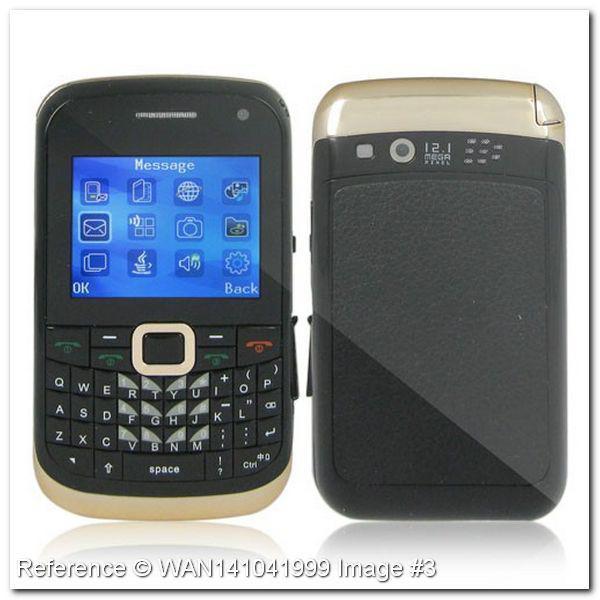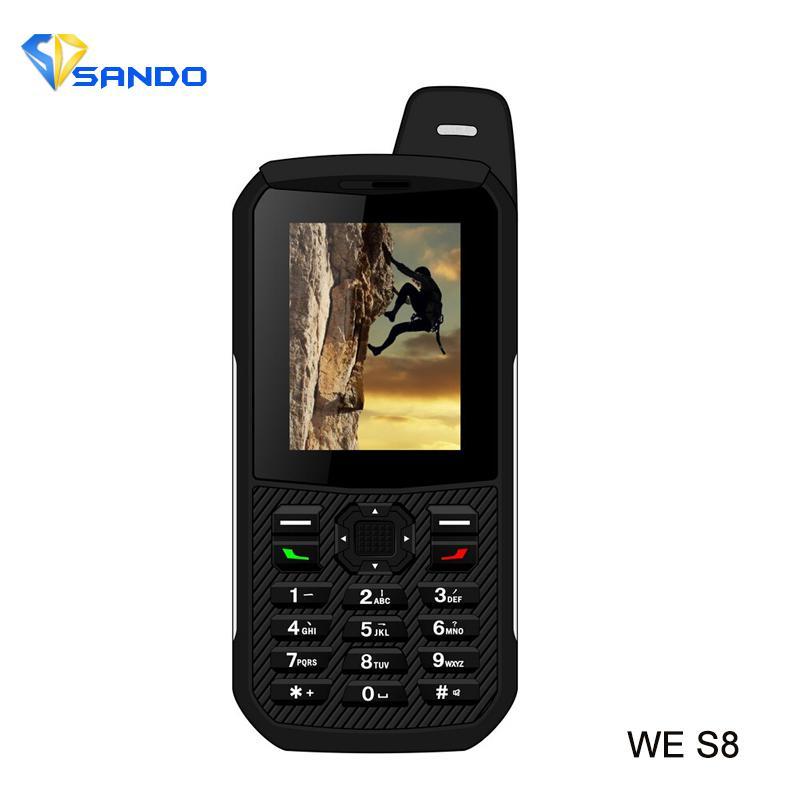The first image is the image on the left, the second image is the image on the right. Assess this claim about the two images: "One image contains just the front side of a phone and the other image shows both the front and back side of a phone.". Correct or not? Answer yes or no. Yes. The first image is the image on the left, the second image is the image on the right. Examine the images to the left and right. Is the description "There are two phones in one of the images and one phone in the other." accurate? Answer yes or no. Yes. 